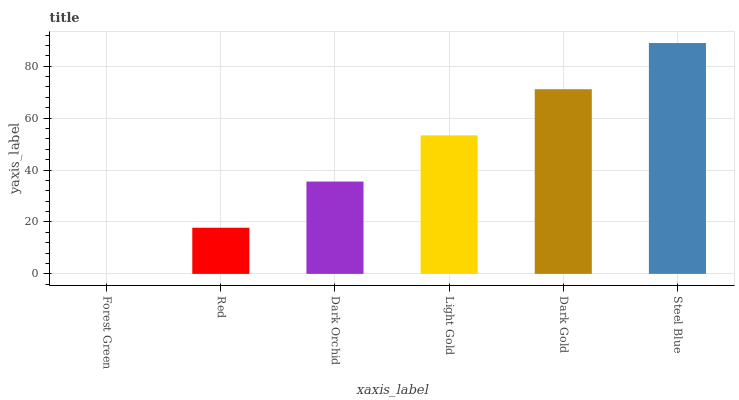Is Forest Green the minimum?
Answer yes or no. Yes. Is Steel Blue the maximum?
Answer yes or no. Yes. Is Red the minimum?
Answer yes or no. No. Is Red the maximum?
Answer yes or no. No. Is Red greater than Forest Green?
Answer yes or no. Yes. Is Forest Green less than Red?
Answer yes or no. Yes. Is Forest Green greater than Red?
Answer yes or no. No. Is Red less than Forest Green?
Answer yes or no. No. Is Light Gold the high median?
Answer yes or no. Yes. Is Dark Orchid the low median?
Answer yes or no. Yes. Is Dark Gold the high median?
Answer yes or no. No. Is Forest Green the low median?
Answer yes or no. No. 